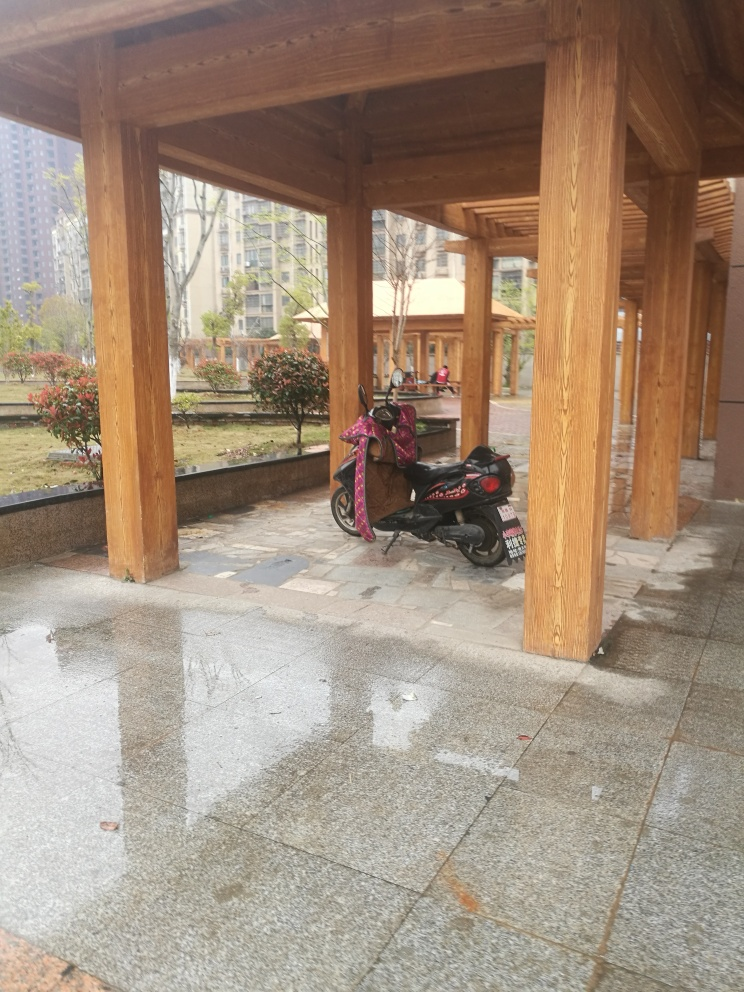What weather conditions might have caused the wet ground in this image? The wet ground and absence of people suggest recent rainfall, or possibly the aftermath of cleaning activities. Given the lack of raindrops in the image and the water's smooth distribution, it's more likely to have been a rain shower that left the ground wet. Does the image display any signs of human activity? The most noticeable sign of human presence is the scooter parked under the structure. The water puddles are undisturbed, which suggests that the area is temporarily devoid of pedestrian traffic. Additionally, there seem to be no people present in the visible parts of the image. 